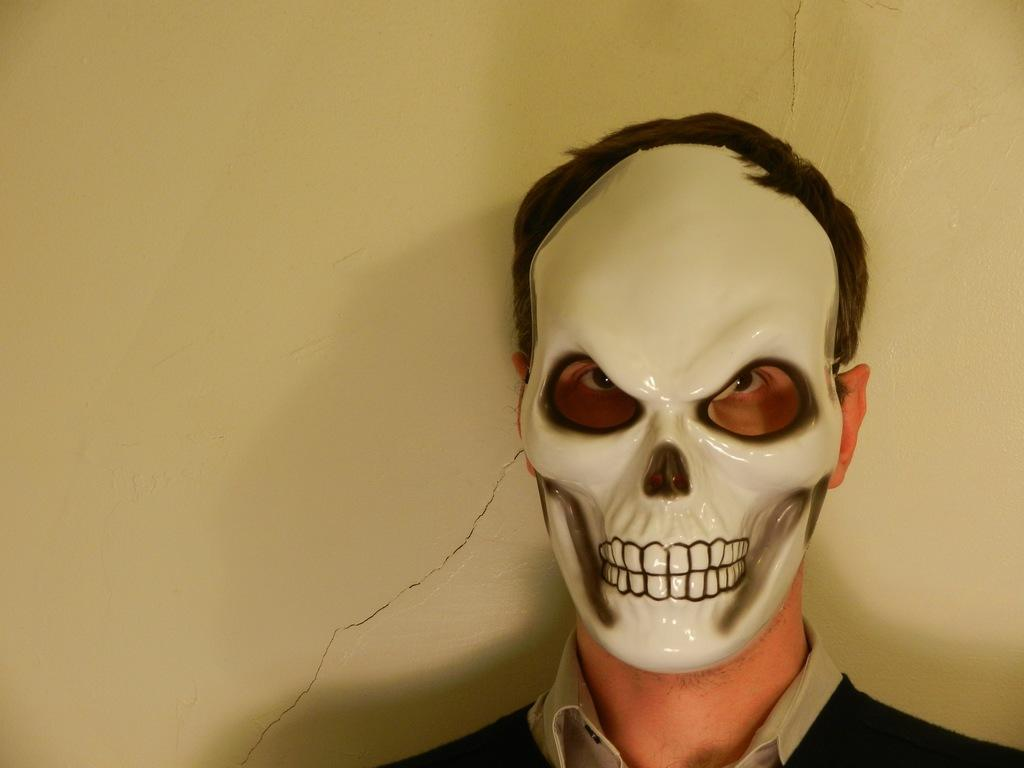What is the person in the image wearing on their face? The person is wearing a skeleton mask in the image. What can be seen in the background of the image? There is a wall in the background of the image. How does the person's digestion process affect the humor in the image? There is no information about the person's digestion process or humor in the image, so it cannot be determined how they might be related. 